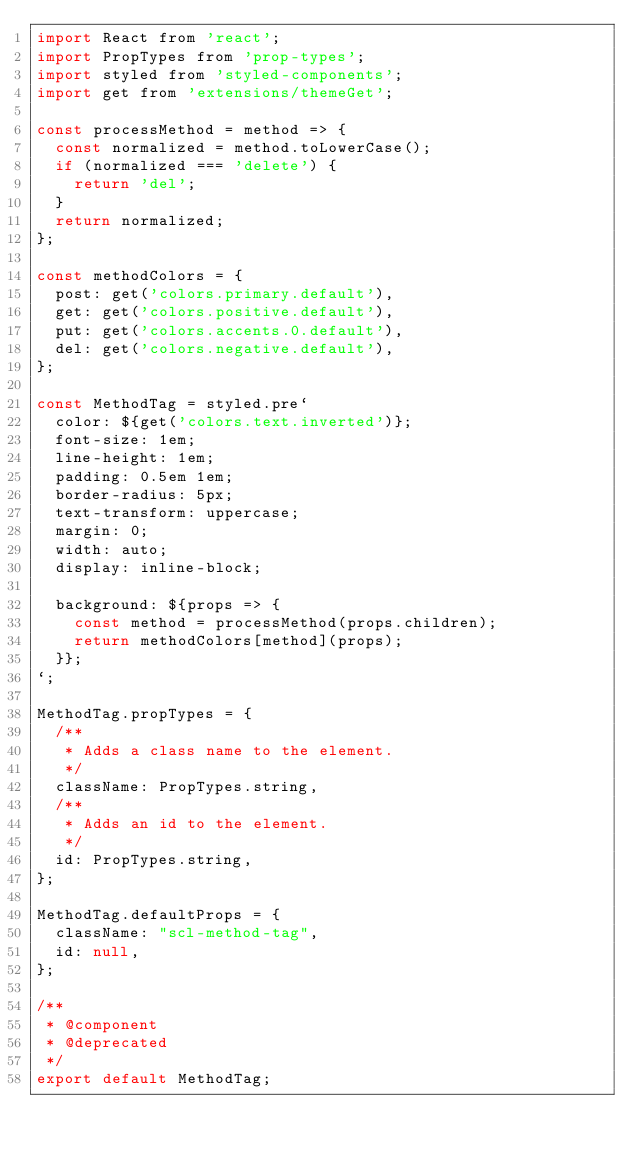Convert code to text. <code><loc_0><loc_0><loc_500><loc_500><_JavaScript_>import React from 'react';
import PropTypes from 'prop-types';
import styled from 'styled-components';
import get from 'extensions/themeGet';

const processMethod = method => {
  const normalized = method.toLowerCase();
  if (normalized === 'delete') {
    return 'del';
  }
  return normalized;
};

const methodColors = {
  post: get('colors.primary.default'),
  get: get('colors.positive.default'),
  put: get('colors.accents.0.default'),
  del: get('colors.negative.default'),
};

const MethodTag = styled.pre`
  color: ${get('colors.text.inverted')};
  font-size: 1em;
  line-height: 1em;
  padding: 0.5em 1em;
  border-radius: 5px;
  text-transform: uppercase;
  margin: 0;
  width: auto;
  display: inline-block;

  background: ${props => {
    const method = processMethod(props.children);
    return methodColors[method](props);
  }};
`;

MethodTag.propTypes = {
  /**
   * Adds a class name to the element.
   */
  className: PropTypes.string,
  /**
   * Adds an id to the element.
   */
  id: PropTypes.string,
};

MethodTag.defaultProps = {
  className: "scl-method-tag",
  id: null,
};

/**
 * @component
 * @deprecated
 */
export default MethodTag;
</code> 